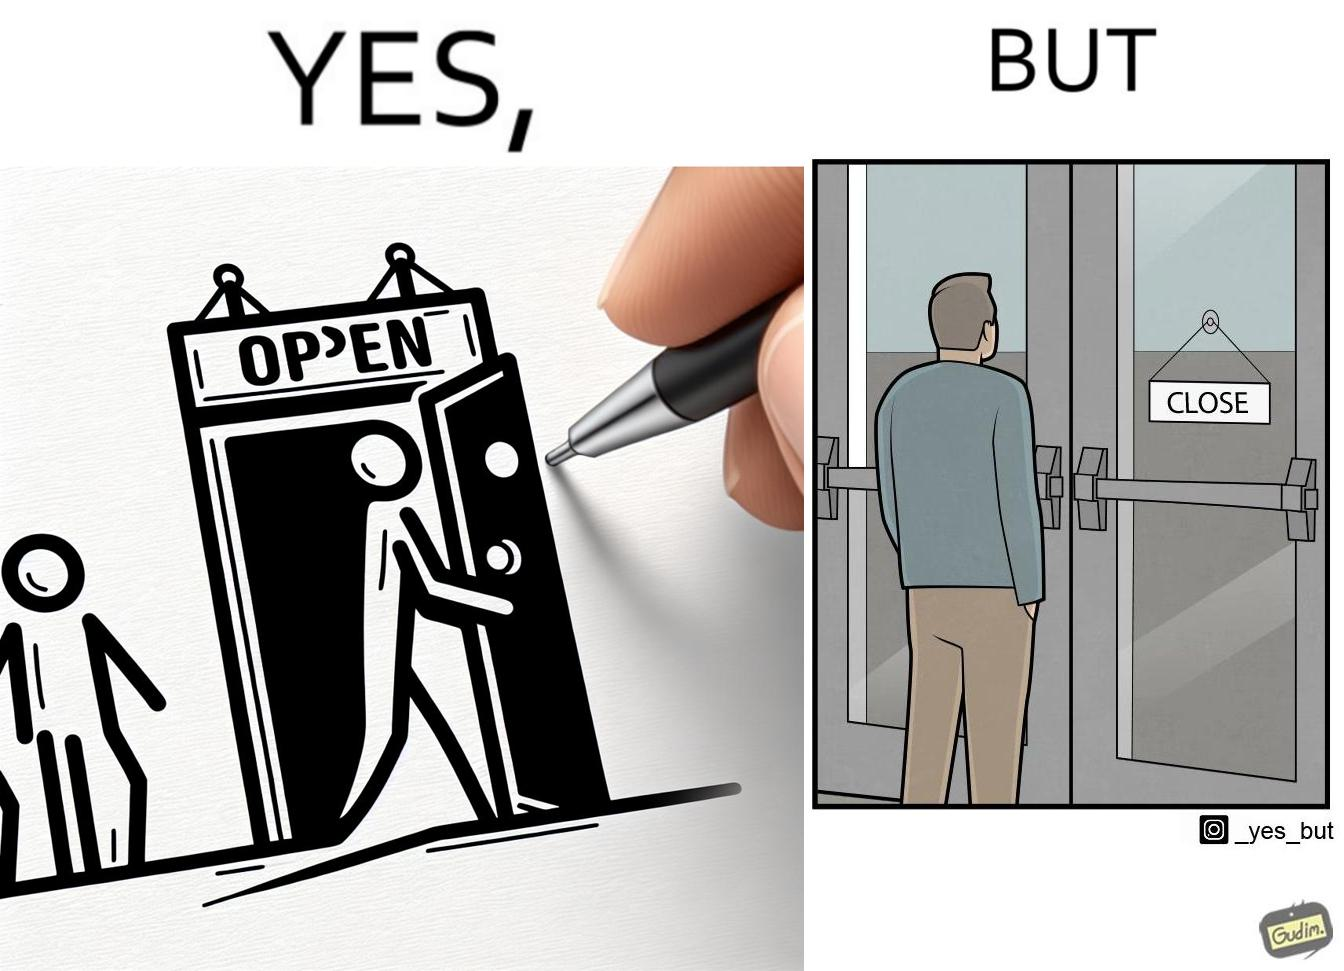Is there satirical content in this image? Yes, this image is satirical. 